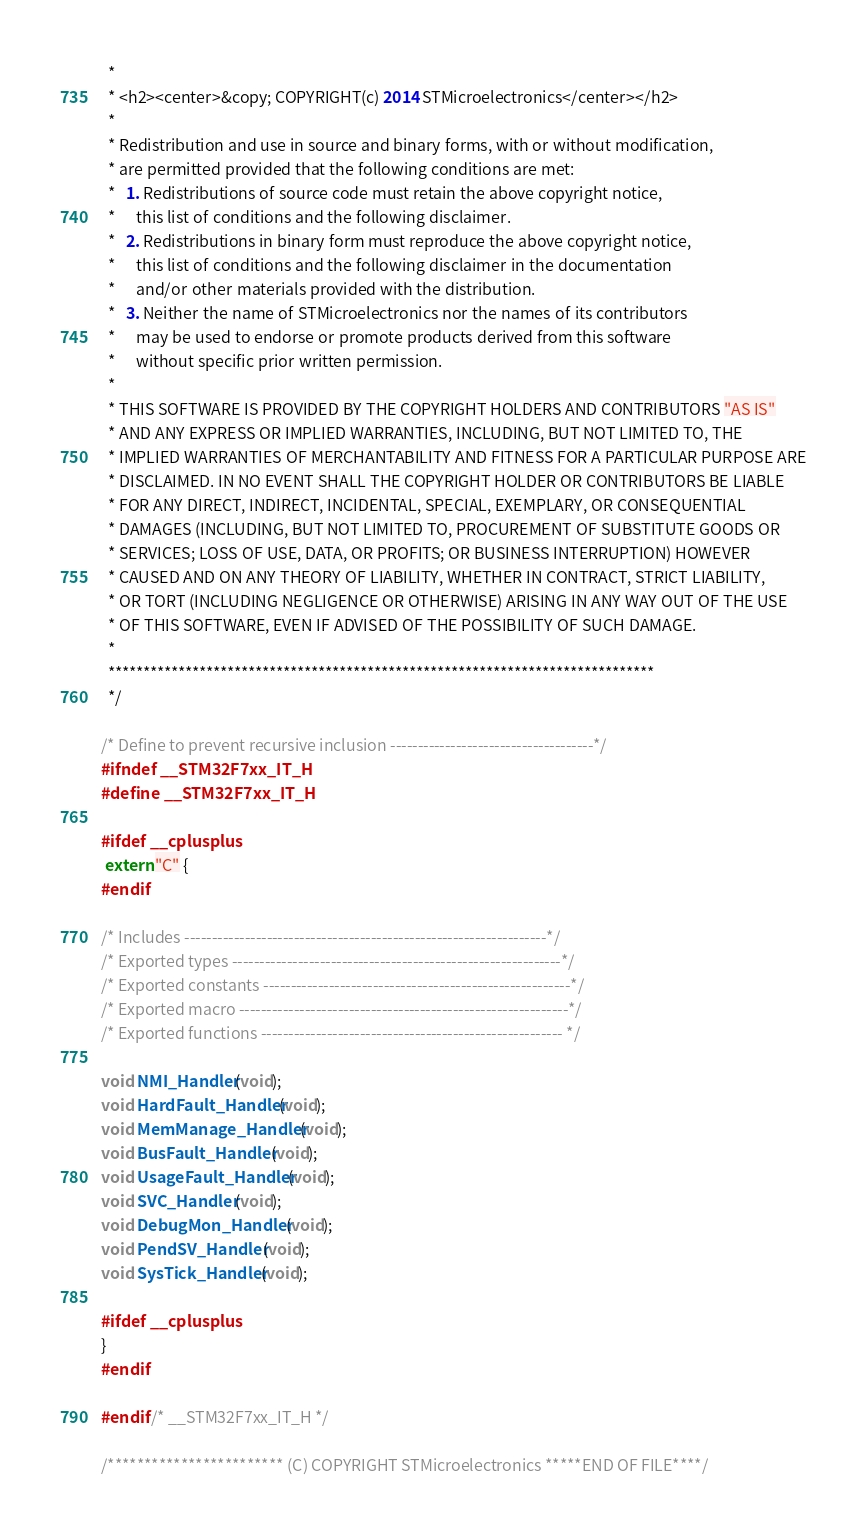<code> <loc_0><loc_0><loc_500><loc_500><_C_>  *
  * <h2><center>&copy; COPYRIGHT(c) 2014 STMicroelectronics</center></h2>
  *
  * Redistribution and use in source and binary forms, with or without modification,
  * are permitted provided that the following conditions are met:
  *   1. Redistributions of source code must retain the above copyright notice,
  *      this list of conditions and the following disclaimer.
  *   2. Redistributions in binary form must reproduce the above copyright notice,
  *      this list of conditions and the following disclaimer in the documentation
  *      and/or other materials provided with the distribution.
  *   3. Neither the name of STMicroelectronics nor the names of its contributors
  *      may be used to endorse or promote products derived from this software
  *      without specific prior written permission.
  *
  * THIS SOFTWARE IS PROVIDED BY THE COPYRIGHT HOLDERS AND CONTRIBUTORS "AS IS"
  * AND ANY EXPRESS OR IMPLIED WARRANTIES, INCLUDING, BUT NOT LIMITED TO, THE
  * IMPLIED WARRANTIES OF MERCHANTABILITY AND FITNESS FOR A PARTICULAR PURPOSE ARE
  * DISCLAIMED. IN NO EVENT SHALL THE COPYRIGHT HOLDER OR CONTRIBUTORS BE LIABLE
  * FOR ANY DIRECT, INDIRECT, INCIDENTAL, SPECIAL, EXEMPLARY, OR CONSEQUENTIAL
  * DAMAGES (INCLUDING, BUT NOT LIMITED TO, PROCUREMENT OF SUBSTITUTE GOODS OR
  * SERVICES; LOSS OF USE, DATA, OR PROFITS; OR BUSINESS INTERRUPTION) HOWEVER
  * CAUSED AND ON ANY THEORY OF LIABILITY, WHETHER IN CONTRACT, STRICT LIABILITY,
  * OR TORT (INCLUDING NEGLIGENCE OR OTHERWISE) ARISING IN ANY WAY OUT OF THE USE
  * OF THIS SOFTWARE, EVEN IF ADVISED OF THE POSSIBILITY OF SUCH DAMAGE.
  *
  ******************************************************************************
  */

/* Define to prevent recursive inclusion -------------------------------------*/
#ifndef __STM32F7xx_IT_H
#define __STM32F7xx_IT_H

#ifdef __cplusplus
 extern "C" {
#endif 

/* Includes ------------------------------------------------------------------*/
/* Exported types ------------------------------------------------------------*/
/* Exported constants --------------------------------------------------------*/
/* Exported macro ------------------------------------------------------------*/
/* Exported functions ------------------------------------------------------- */

void NMI_Handler(void);
void HardFault_Handler(void);
void MemManage_Handler(void);
void BusFault_Handler(void);
void UsageFault_Handler(void);
void SVC_Handler(void);
void DebugMon_Handler(void);
void PendSV_Handler(void);
void SysTick_Handler(void);

#ifdef __cplusplus
}
#endif

#endif /* __STM32F7xx_IT_H */

/************************ (C) COPYRIGHT STMicroelectronics *****END OF FILE****/
</code> 